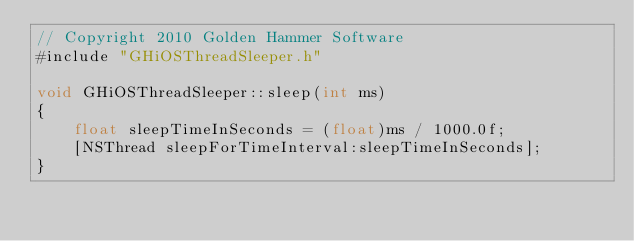<code> <loc_0><loc_0><loc_500><loc_500><_ObjectiveC_>// Copyright 2010 Golden Hammer Software
#include "GHiOSThreadSleeper.h"

void GHiOSThreadSleeper::sleep(int ms) 
{
	float sleepTimeInSeconds = (float)ms / 1000.0f;
	[NSThread sleepForTimeInterval:sleepTimeInSeconds];
}
</code> 